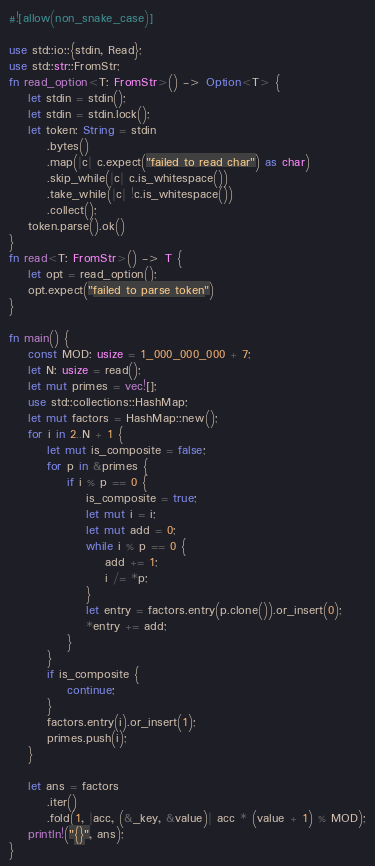<code> <loc_0><loc_0><loc_500><loc_500><_Rust_>#![allow(non_snake_case)]

use std::io::{stdin, Read};
use std::str::FromStr;
fn read_option<T: FromStr>() -> Option<T> {
    let stdin = stdin();
    let stdin = stdin.lock();
    let token: String = stdin
        .bytes()
        .map(|c| c.expect("failed to read char") as char)
        .skip_while(|c| c.is_whitespace())
        .take_while(|c| !c.is_whitespace())
        .collect();
    token.parse().ok()
}
fn read<T: FromStr>() -> T {
    let opt = read_option();
    opt.expect("failed to parse token")
}

fn main() {
    const MOD: usize = 1_000_000_000 + 7;
    let N: usize = read();
    let mut primes = vec![];
    use std::collections::HashMap;
    let mut factors = HashMap::new();
    for i in 2..N + 1 {
        let mut is_composite = false;
        for p in &primes {
            if i % p == 0 {
                is_composite = true;
                let mut i = i;
                let mut add = 0;
                while i % p == 0 {
                    add += 1;
                    i /= *p;
                }
                let entry = factors.entry(p.clone()).or_insert(0);
                *entry += add;
            }
        }
        if is_composite {
            continue;
        }
        factors.entry(i).or_insert(1);
        primes.push(i);
    }

    let ans = factors
        .iter()
        .fold(1, |acc, (&_key, &value)| acc * (value + 1) % MOD);
    println!("{}", ans);
}
</code> 